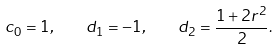Convert formula to latex. <formula><loc_0><loc_0><loc_500><loc_500>c _ { 0 } = 1 , \quad d _ { 1 } = - 1 , \quad d _ { 2 } = \frac { 1 + 2 r ^ { 2 } } { 2 } .</formula> 